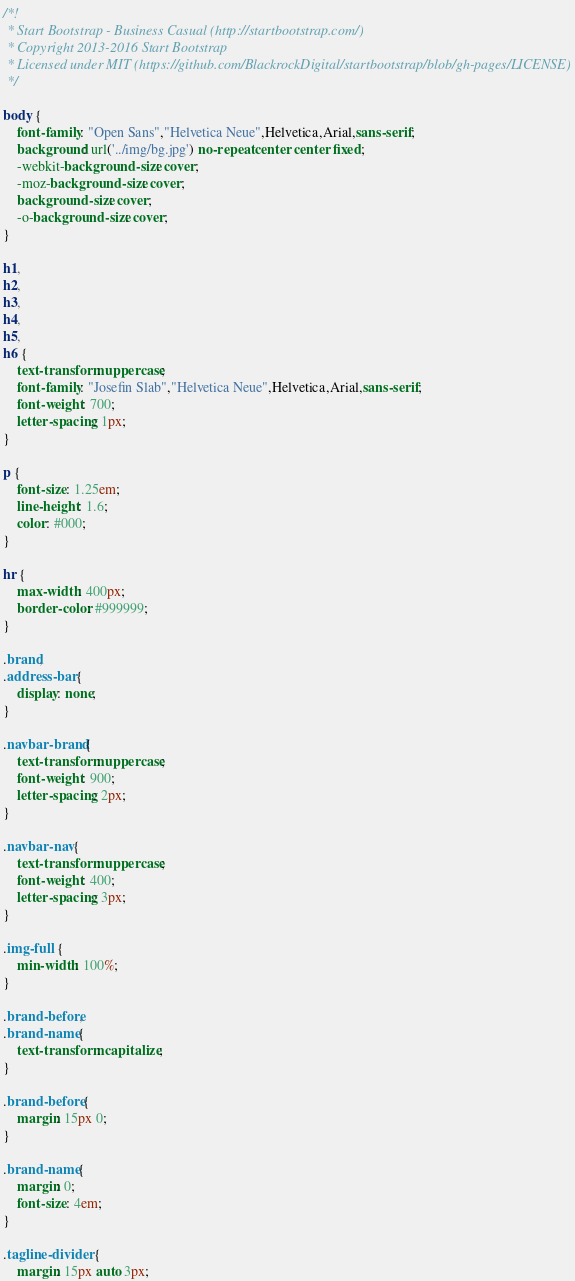<code> <loc_0><loc_0><loc_500><loc_500><_CSS_>/*!
 * Start Bootstrap - Business Casual (http://startbootstrap.com/)
 * Copyright 2013-2016 Start Bootstrap
 * Licensed under MIT (https://github.com/BlackrockDigital/startbootstrap/blob/gh-pages/LICENSE)
 */

body {
    font-family: "Open Sans","Helvetica Neue",Helvetica,Arial,sans-serif;
    background: url('../img/bg.jpg') no-repeat center center fixed;
    -webkit-background-size: cover;
    -moz-background-size: cover;
    background-size: cover;
    -o-background-size: cover;
}

h1,
h2,
h3,
h4,
h5,
h6 {
    text-transform: uppercase;
    font-family: "Josefin Slab","Helvetica Neue",Helvetica,Arial,sans-serif;
    font-weight: 700;
    letter-spacing: 1px;
}

p {
    font-size: 1.25em;
    line-height: 1.6;
    color: #000;
}

hr {
    max-width: 400px;
    border-color: #999999;
}

.brand,
.address-bar {
    display: none;
}

.navbar-brand {
    text-transform: uppercase;
    font-weight: 900;
    letter-spacing: 2px;
}

.navbar-nav {
    text-transform: uppercase;
    font-weight: 400;
    letter-spacing: 3px;
}

.img-full {
    min-width: 100%;
}

.brand-before,
.brand-name {
    text-transform: capitalize;
}

.brand-before {
    margin: 15px 0;
}

.brand-name {
    margin: 0;
    font-size: 4em;
}

.tagline-divider {
    margin: 15px auto 3px;</code> 